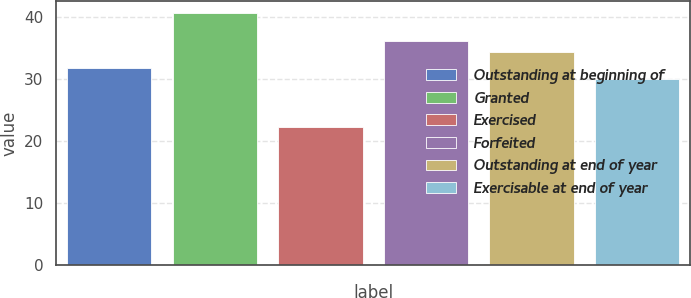<chart> <loc_0><loc_0><loc_500><loc_500><bar_chart><fcel>Outstanding at beginning of<fcel>Granted<fcel>Exercised<fcel>Forfeited<fcel>Outstanding at end of year<fcel>Exercisable at end of year<nl><fcel>31.81<fcel>40.66<fcel>22.34<fcel>36.15<fcel>34.32<fcel>29.98<nl></chart> 